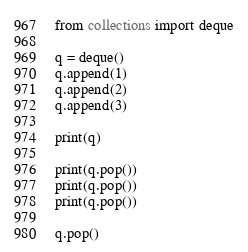Convert code to text. <code><loc_0><loc_0><loc_500><loc_500><_Python_>from collections import deque

q = deque()
q.append(1)
q.append(2)
q.append(3)

print(q)

print(q.pop())
print(q.pop())
print(q.pop())

q.pop()
</code> 